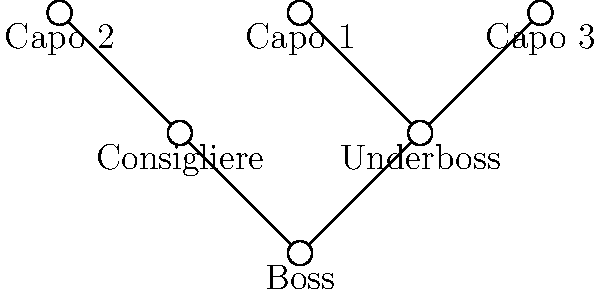As a crime novelist researching organized crime structures, you come across this organizational chart of a criminal network. Based on the hierarchy shown, which position is most likely responsible for managing day-to-day operations and relaying orders from the top leadership to the lower ranks? To answer this question, we need to analyze the organizational structure presented in the chart:

1. At the top of the chart, we see the "Boss," who is the overall leader of the criminal organization.

2. Directly below the Boss, we see two positions:
   a) "Underboss" on the right
   b) "Consigliere" on the left

3. Below these two positions, we see three "Capo" positions, with two connected to the Underboss and one to the Consigliere.

4. In typical criminal organizations:
   - The Boss is the ultimate authority but often removed from daily operations.
   - The Consigliere is usually an advisor to the Boss, not directly involved in the chain of command.
   - The Underboss is second-in-command and typically responsible for overseeing daily operations and communicating orders from the Boss to lower ranks.

5. Given this structure and typical roles, the Underboss is most likely to be responsible for managing day-to-day operations and relaying orders from the top leadership (the Boss) to the lower ranks (the Capos).

Therefore, the position most likely responsible for managing day-to-day operations and relaying orders from the top leadership to the lower ranks is the Underboss.
Answer: Underboss 